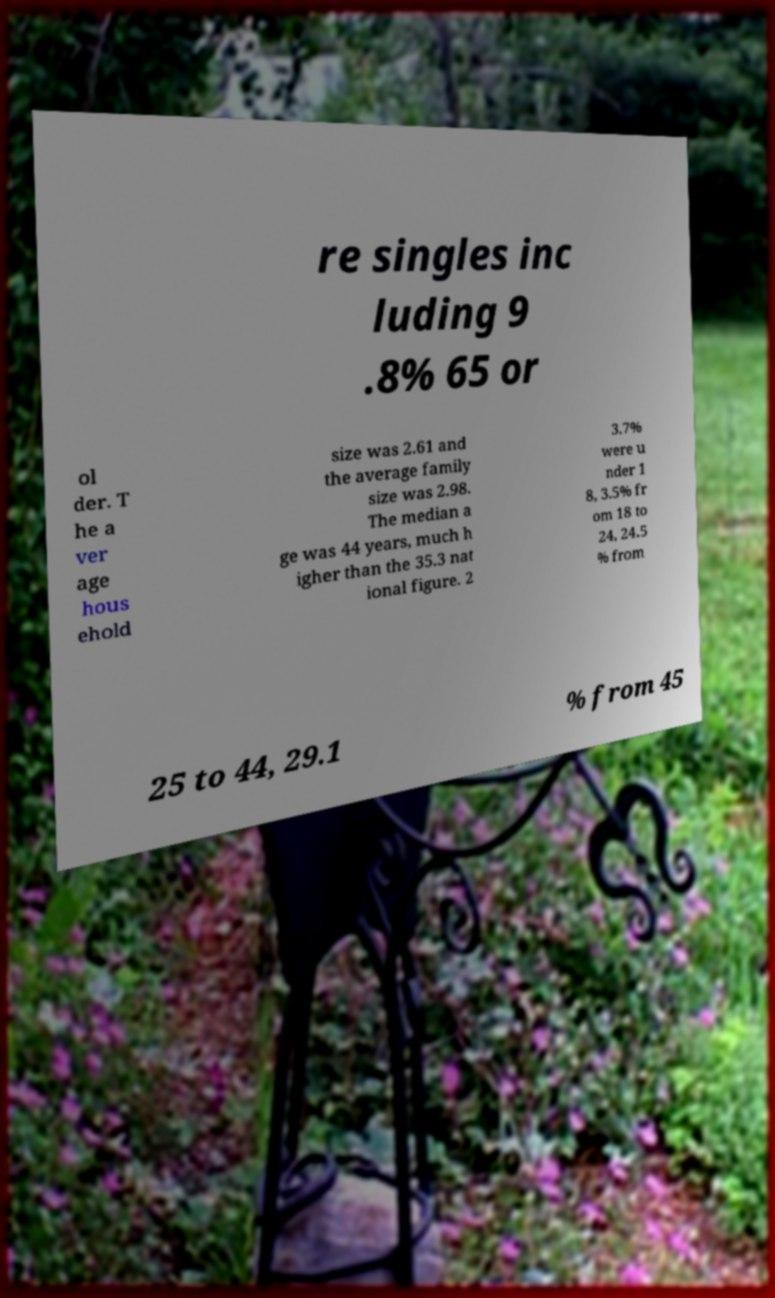There's text embedded in this image that I need extracted. Can you transcribe it verbatim? re singles inc luding 9 .8% 65 or ol der. T he a ver age hous ehold size was 2.61 and the average family size was 2.98. The median a ge was 44 years, much h igher than the 35.3 nat ional figure. 2 3.7% were u nder 1 8, 3.5% fr om 18 to 24, 24.5 % from 25 to 44, 29.1 % from 45 